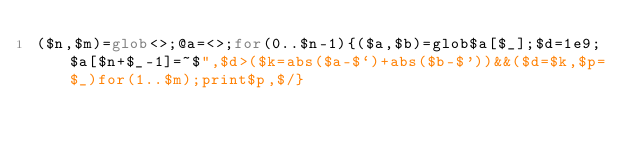Convert code to text. <code><loc_0><loc_0><loc_500><loc_500><_Perl_>($n,$m)=glob<>;@a=<>;for(0..$n-1){($a,$b)=glob$a[$_];$d=1e9;$a[$n+$_-1]=~$",$d>($k=abs($a-$`)+abs($b-$'))&&($d=$k,$p=$_)for(1..$m);print$p,$/}</code> 